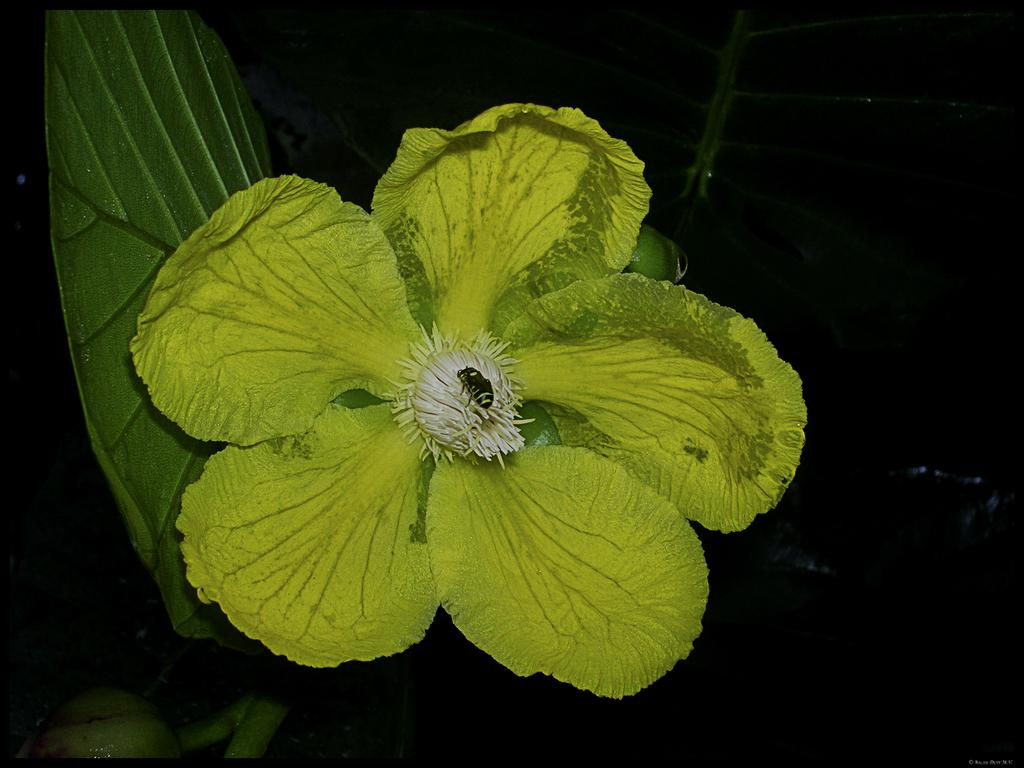What is the main subject of the image? The main subject of the image is a flower. What color is the flower in the image? The flower is green in color. Can you describe anything else visible in the image? There is a leaf behind the flower. What type of hat can be seen on the flower in the image? There is no hat present on the flower in the image. What rhythm is the flower following in the image? The flower is not following any rhythm in the image; it is a still image of a flower. 